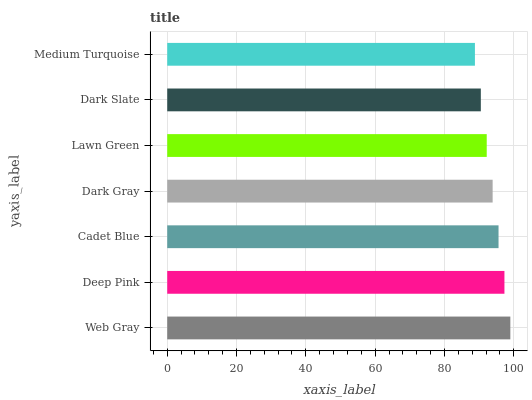Is Medium Turquoise the minimum?
Answer yes or no. Yes. Is Web Gray the maximum?
Answer yes or no. Yes. Is Deep Pink the minimum?
Answer yes or no. No. Is Deep Pink the maximum?
Answer yes or no. No. Is Web Gray greater than Deep Pink?
Answer yes or no. Yes. Is Deep Pink less than Web Gray?
Answer yes or no. Yes. Is Deep Pink greater than Web Gray?
Answer yes or no. No. Is Web Gray less than Deep Pink?
Answer yes or no. No. Is Dark Gray the high median?
Answer yes or no. Yes. Is Dark Gray the low median?
Answer yes or no. Yes. Is Dark Slate the high median?
Answer yes or no. No. Is Deep Pink the low median?
Answer yes or no. No. 